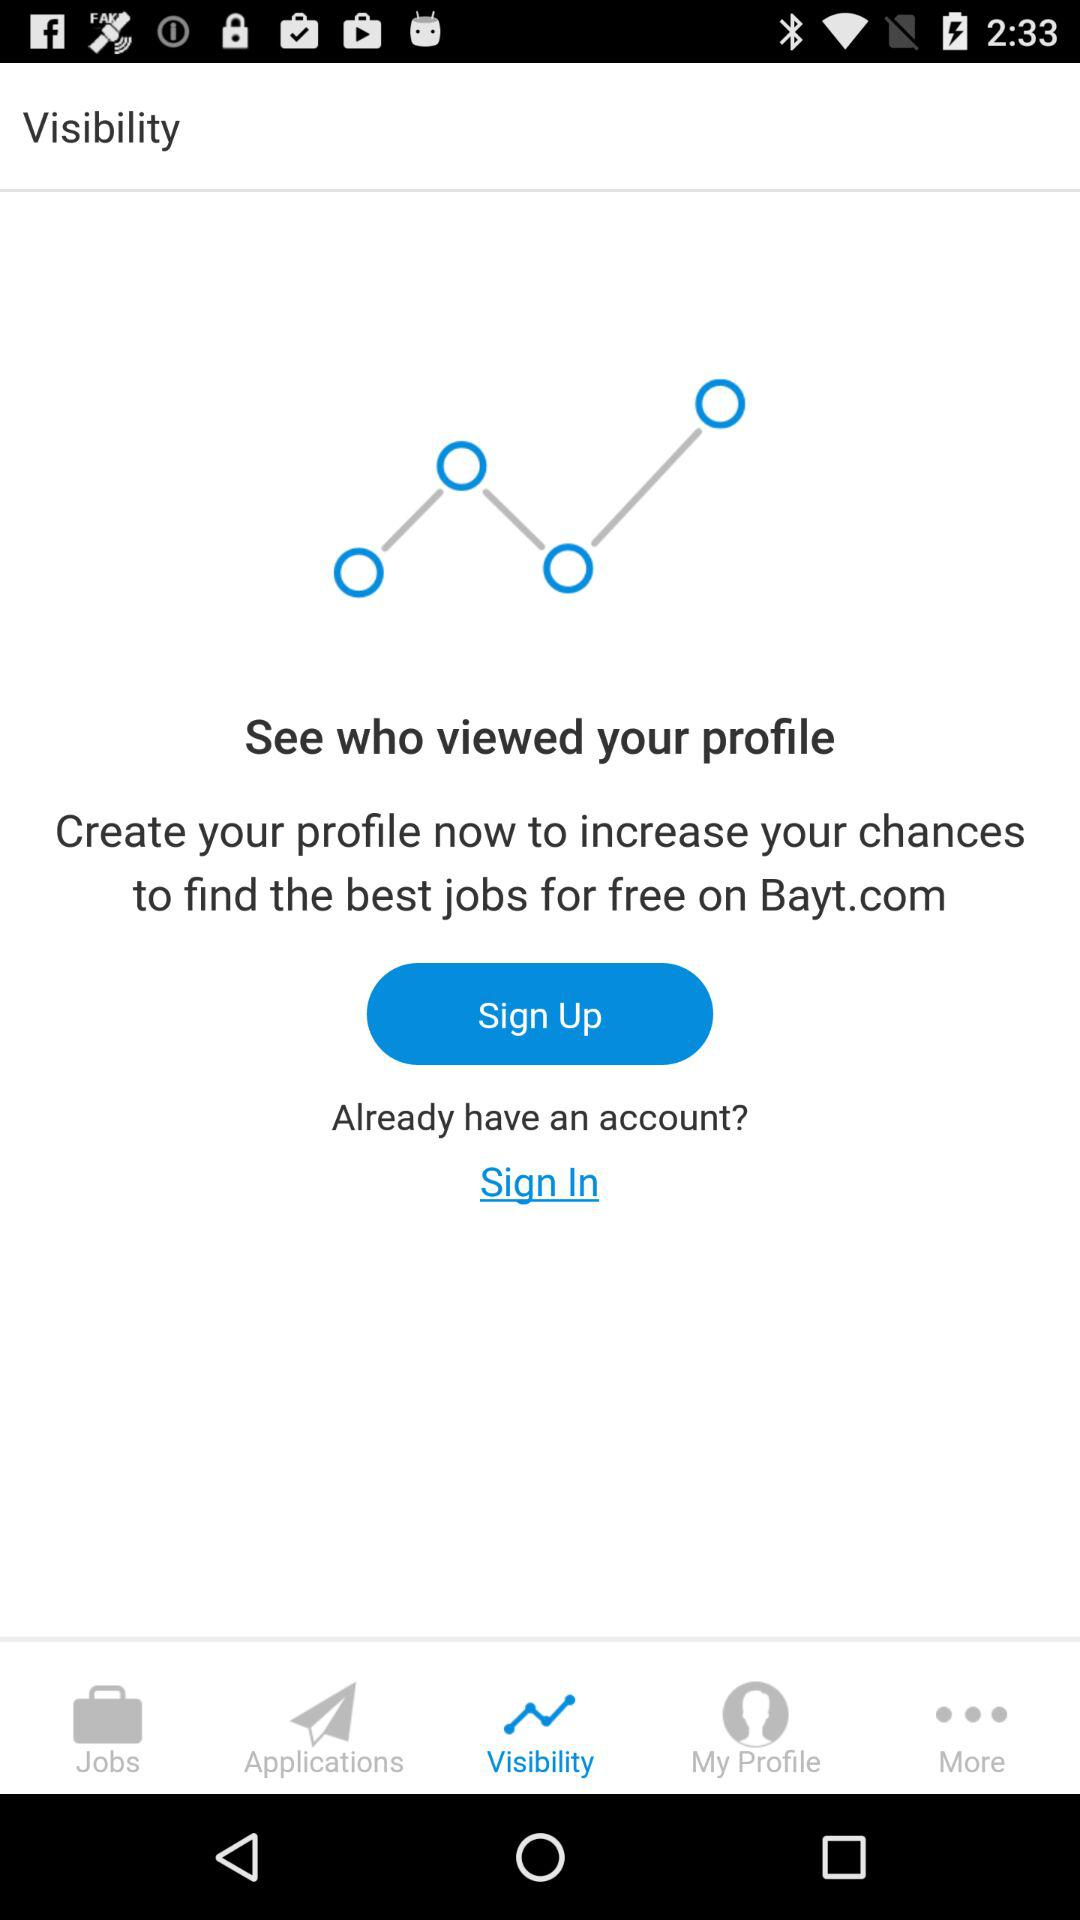What is the name of the application? The name of the application is "Bayt.com". 